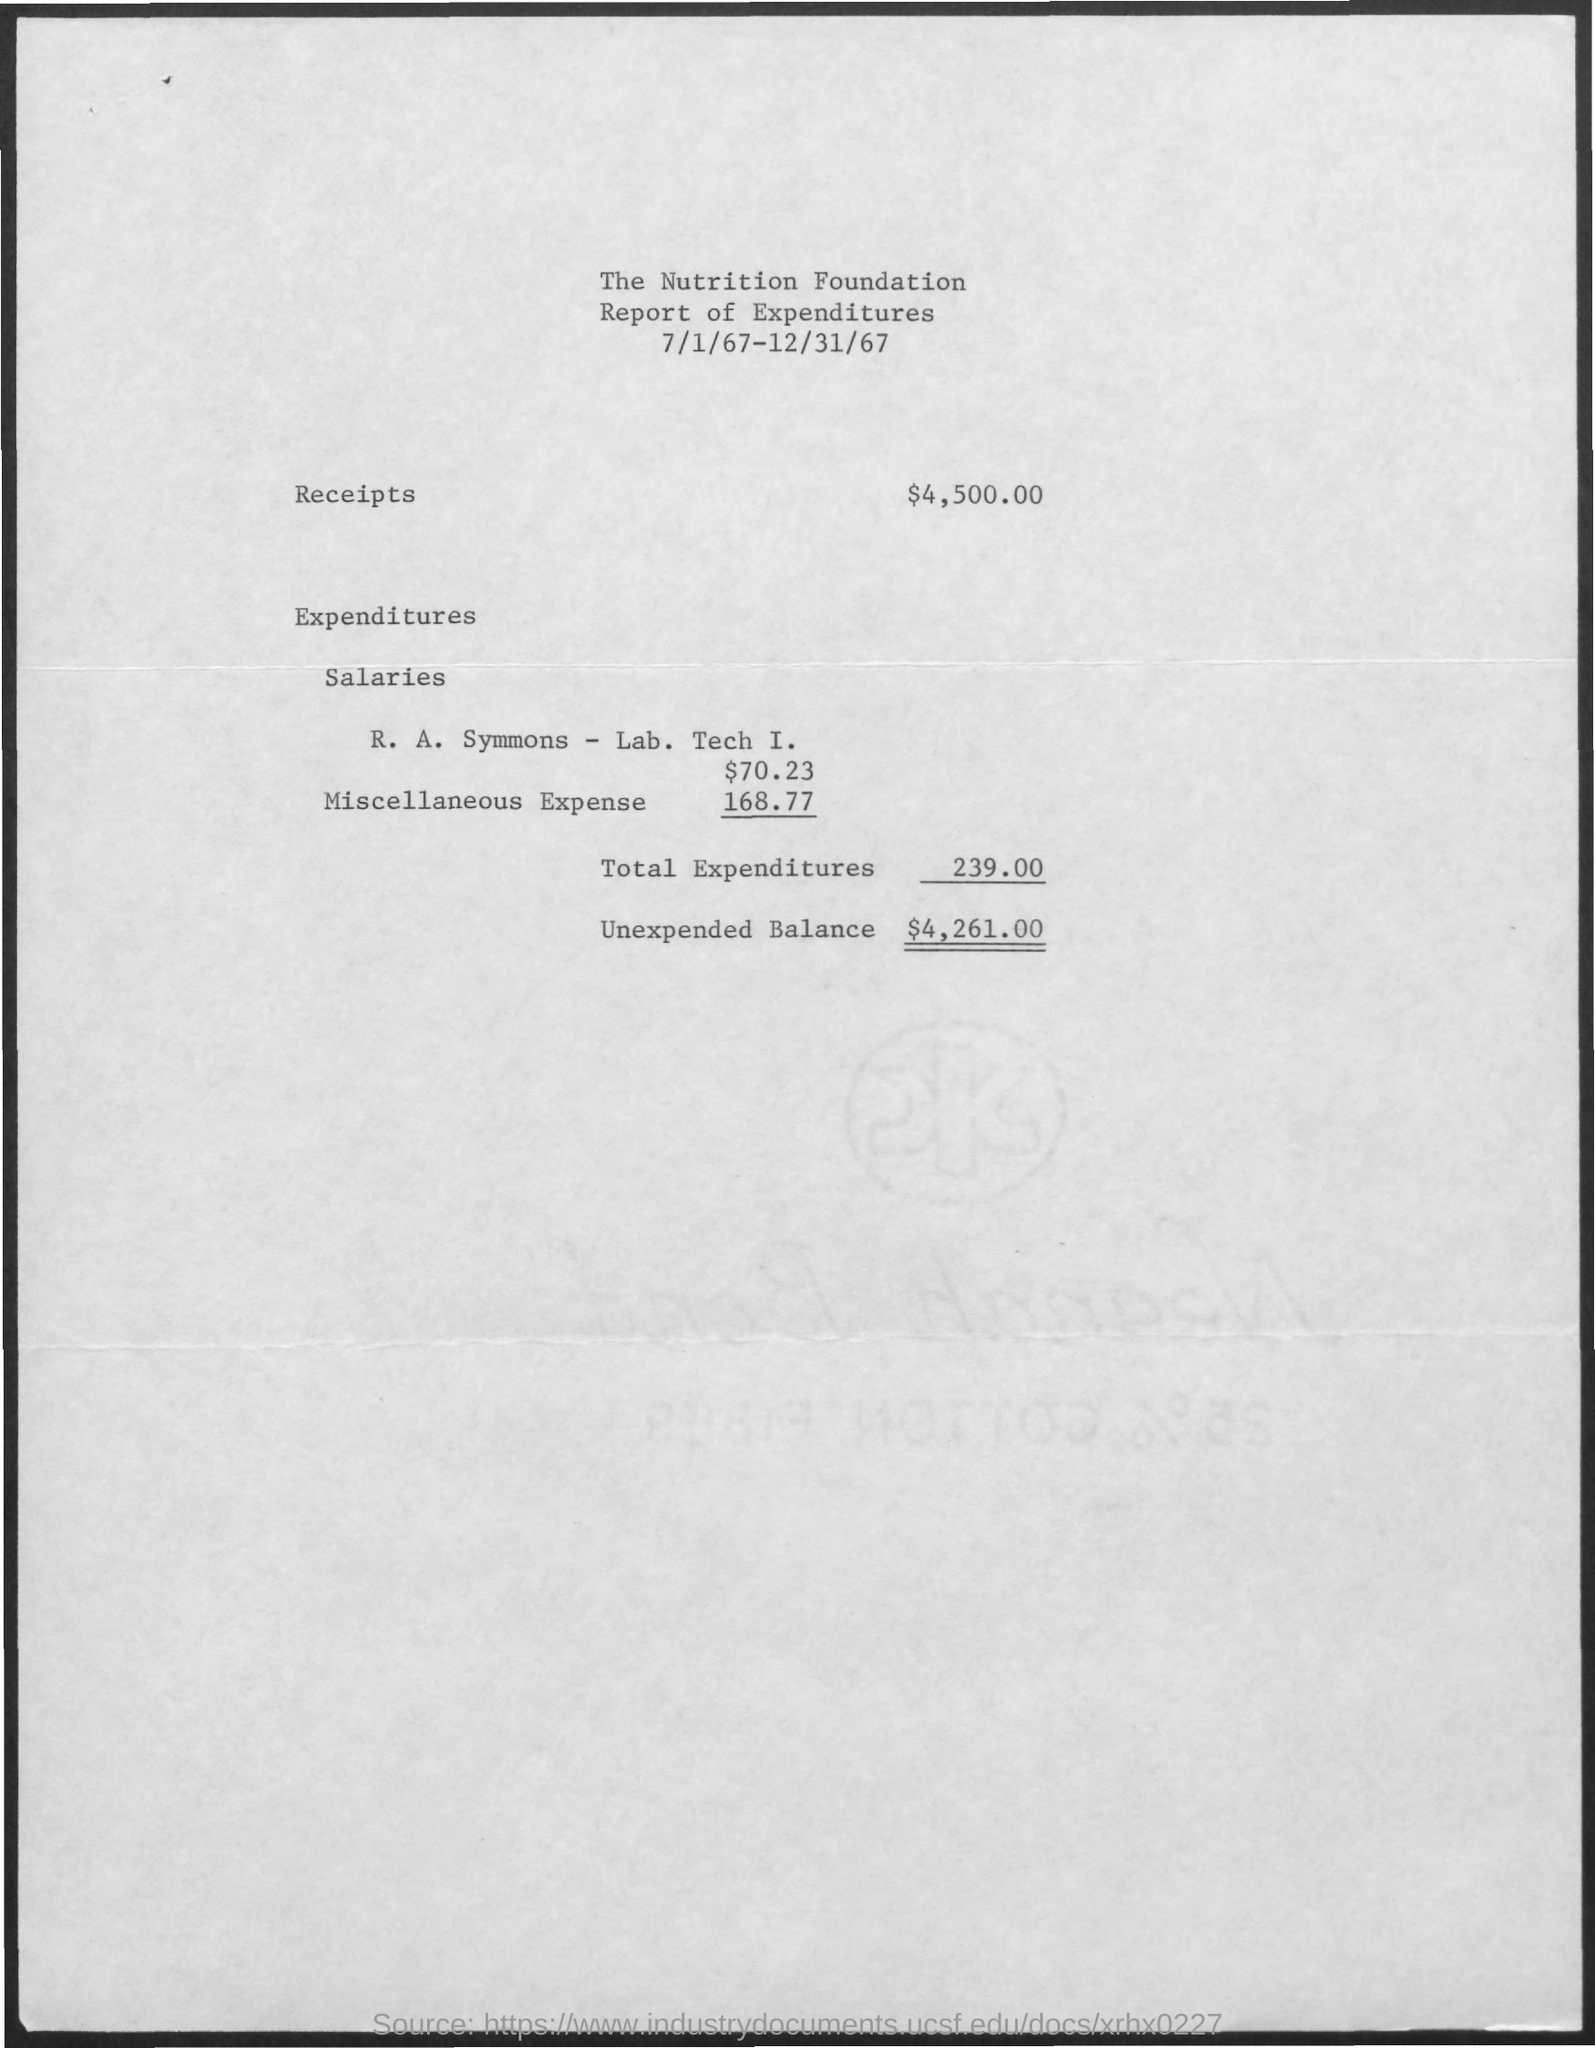What is the document title?
Ensure brevity in your answer.  The Nutrition Foundation Report of Expenditures. When is the document dated?
Keep it short and to the point. 7/1/67-12/31/67. How much is the "Total Expenditures"?
Offer a very short reply. 239.00. 